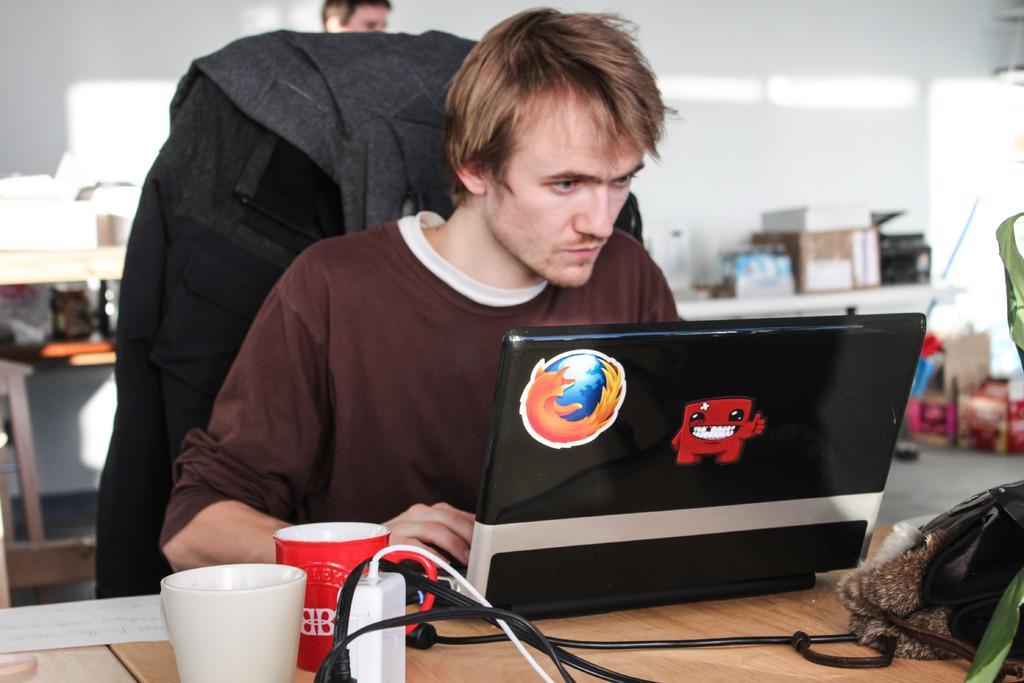Describe this image in one or two sentences. In this image there is one person sitting on the chair as we can see at middle of this image and there is a laptop at bottom of this image which is in black color and there is a fire fox logo on it and there is a table at bottom of this image and there are two cups, white color cup is at left side of this image and red color cup is it right side. They both cups are kept on this table. There is one another person is standing at top of this image and there are some objects kept on a table which is at right of this image. there is a power supply cable at bottom of this image and there are some other objects at left side of this image. 